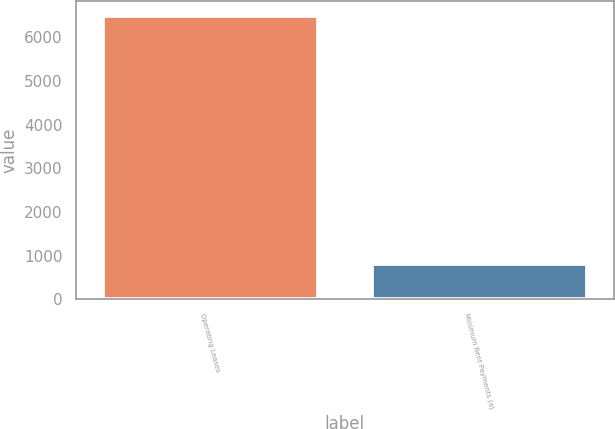<chart> <loc_0><loc_0><loc_500><loc_500><bar_chart><fcel>Operating Leases<fcel>Minimum Rent Payments (a)<nl><fcel>6491<fcel>813<nl></chart> 